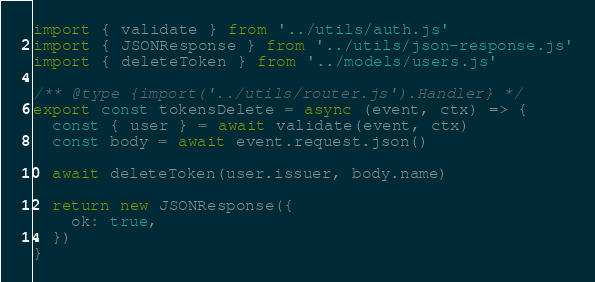<code> <loc_0><loc_0><loc_500><loc_500><_JavaScript_>import { validate } from '../utils/auth.js'
import { JSONResponse } from '../utils/json-response.js'
import { deleteToken } from '../models/users.js'

/** @type {import('../utils/router.js').Handler} */
export const tokensDelete = async (event, ctx) => {
  const { user } = await validate(event, ctx)
  const body = await event.request.json()

  await deleteToken(user.issuer, body.name)

  return new JSONResponse({
    ok: true,
  })
}
</code> 